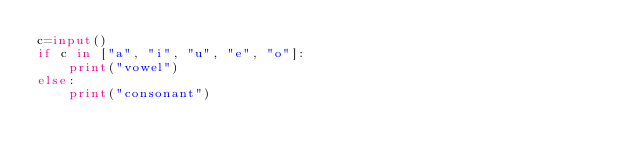<code> <loc_0><loc_0><loc_500><loc_500><_Python_>c=input()
if c in ["a", "i", "u", "e", "o"]:
    print("vowel")
else:
    print("consonant")
</code> 